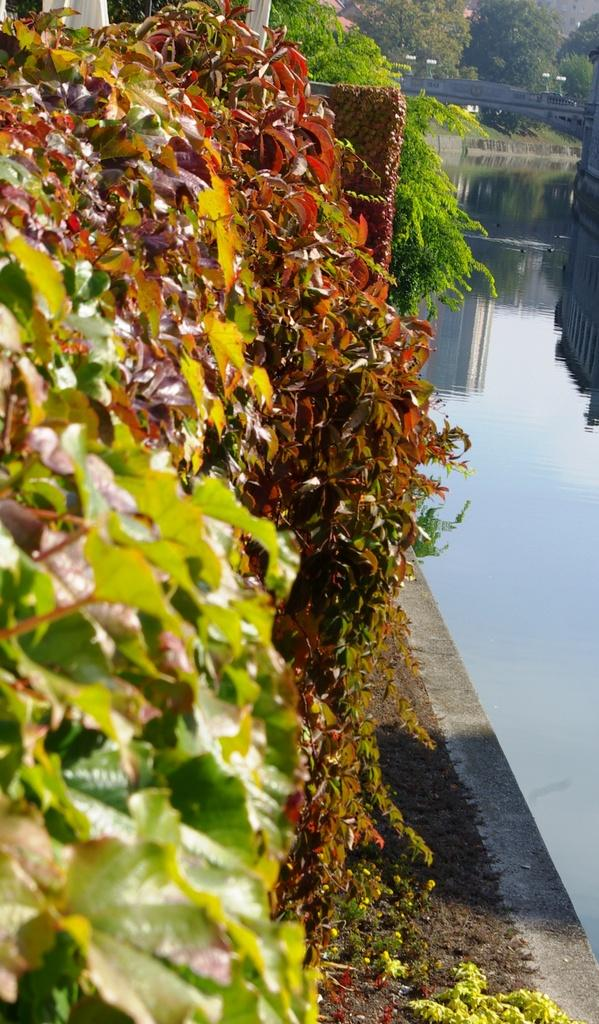What type of natural feature is present in the image? There is a lake in the image. What type of vegetation can be seen in the image? There are trees and plants in the image. What type of income can be seen in the image? There is no reference to income in the image; it features a lake, trees, and plants. 